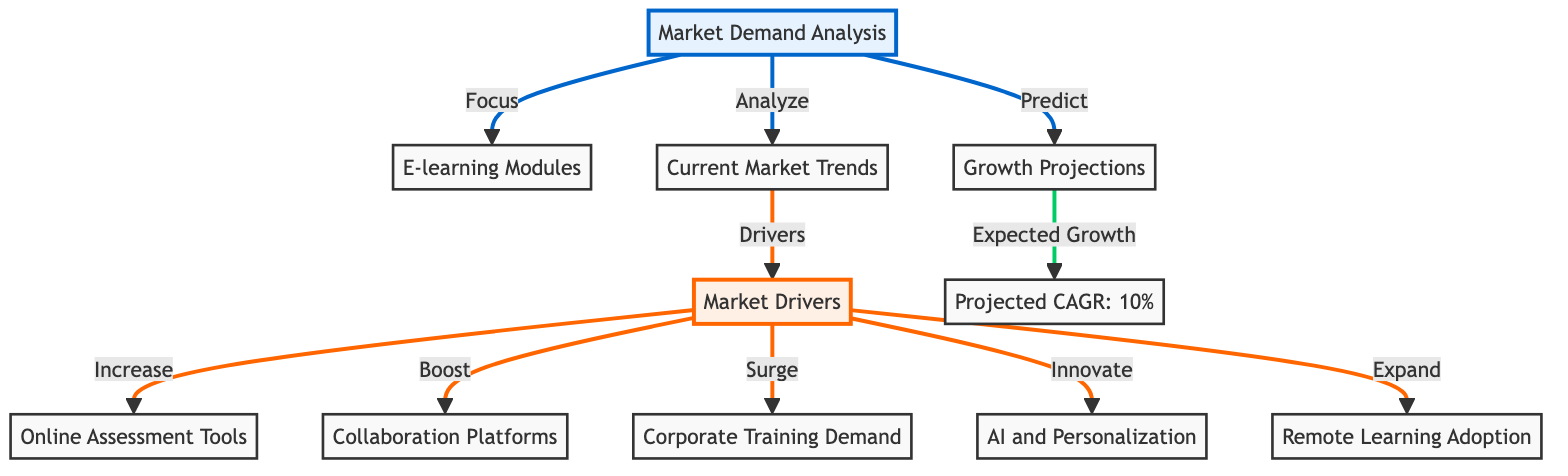What is the expected CAGR for the market? The diagram indicates that the expected Compound Annual Growth Rate (CAGR) is represented in node 11, labeled as "Projected CAGR: 10%."
Answer: 10% How many market drivers are identified in the analysis? The diagram shows the main market drivers connected to node 5. These drivers include Online Assessment Tools, Collaboration Platforms, Corporate Training Demand, AI and Personalization, and Remote Learning Adoption, leading to a total of five drivers.
Answer: 5 Which node represents Corporate Training Demand? The diagram connects Corporate Training Demand, which is labeled in node 8, back to the main driver node (node 5), showing it as one of the market drivers in the analysis.
Answer: Corporate Training Demand What is the relationship between Current Market Trends and Market Drivers? The diagram illustrates that Current Market Trends (node 3) is influenced by Market Drivers (node 5), showing a directed link that suggests the drivers are key factors in shaping the trends.
Answer: Drivers influence trends Which e-learning modules are directly connected to Market Drivers? The diagram presents three modules directly linked to Market Drivers (node 5), namely Online Assessment Tools (node 6), Collaboration Platforms (node 7), and Corporate Training Demand (node 8), indicating their relationship.
Answer: Online Assessment Tools, Collaboration Platforms, Corporate Training Demand What is the significance of node 4 in the diagram? Node 4 represents Growth Projections and is connected to the analysis node, meaning it provides predictions on how the market will evolve based on the trends and drivers identified. This connection suggests a forward-looking perspective on market growth.
Answer: Growth Projections indicate future market evolution How does Remote Learning Adoption relate to Market Drivers? The diagram describes Remote Learning Adoption (node 10) as one of the key components that "expand" the Market Drivers (node 5). This indicates that increased adoption contributes positively to the market's growth.
Answer: Remote Learning Adoption expands Market Drivers What type of diagram is this? Based on its structure and the way it presents relationships and analyses in a clearly defined flow, this is classified as a Textbook Diagram, often used for educational or analytical purposes.
Answer: Textbook Diagram 